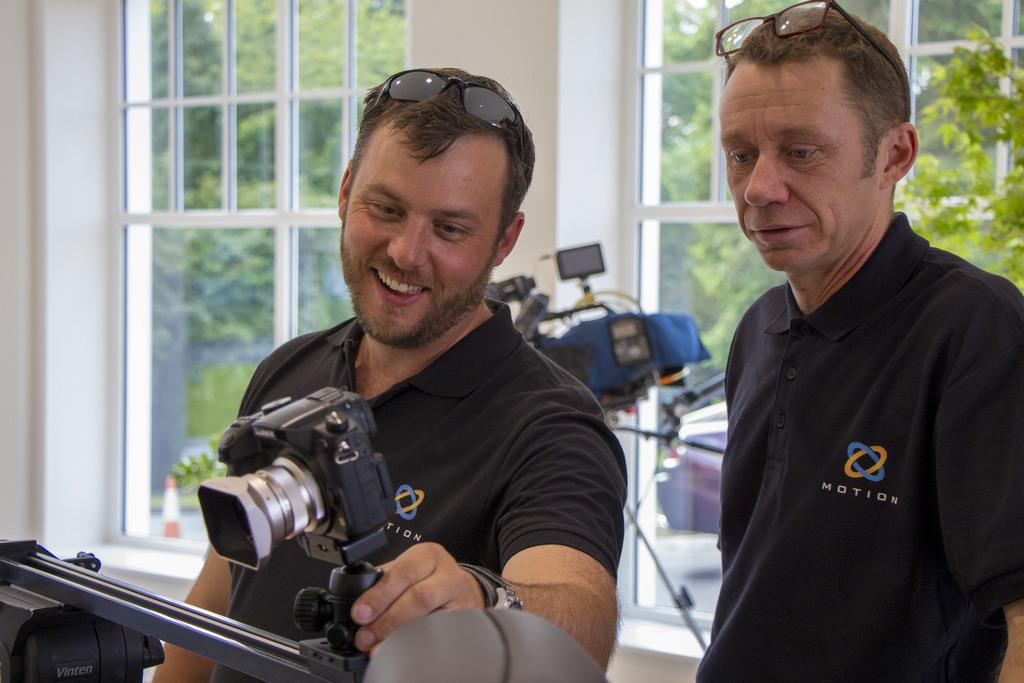How many people are in the image? There are two persons in the image. What are the two persons doing in the image? The two persons are standing. Can you describe what the man is holding in the image? The man is holding a camera. What can be seen through the window in the image? Trees are visible through the window. What type of drug is the man taking in the image? There is no indication of any drug in the image; the man is holding a camera. How many cubs are visible in the image? There are no cubs present in the image. 